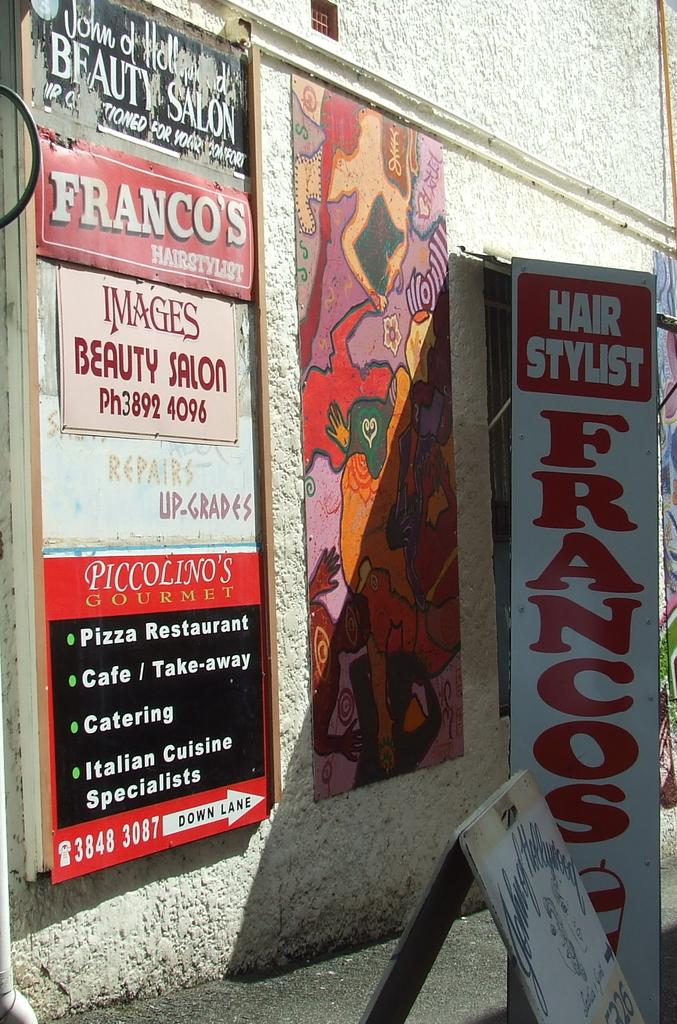<image>
Render a clear and concise summary of the photo. Signs hang on a building outside advertising Franco's and other beauty salons. 